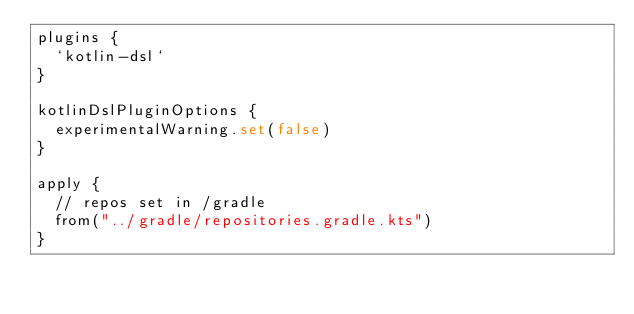<code> <loc_0><loc_0><loc_500><loc_500><_Kotlin_>plugins {
  `kotlin-dsl`
}

kotlinDslPluginOptions {
  experimentalWarning.set(false)
}

apply {
  // repos set in /gradle
  from("../gradle/repositories.gradle.kts")
}
</code> 